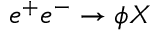<formula> <loc_0><loc_0><loc_500><loc_500>e ^ { + } e ^ { - } \to \phi X</formula> 